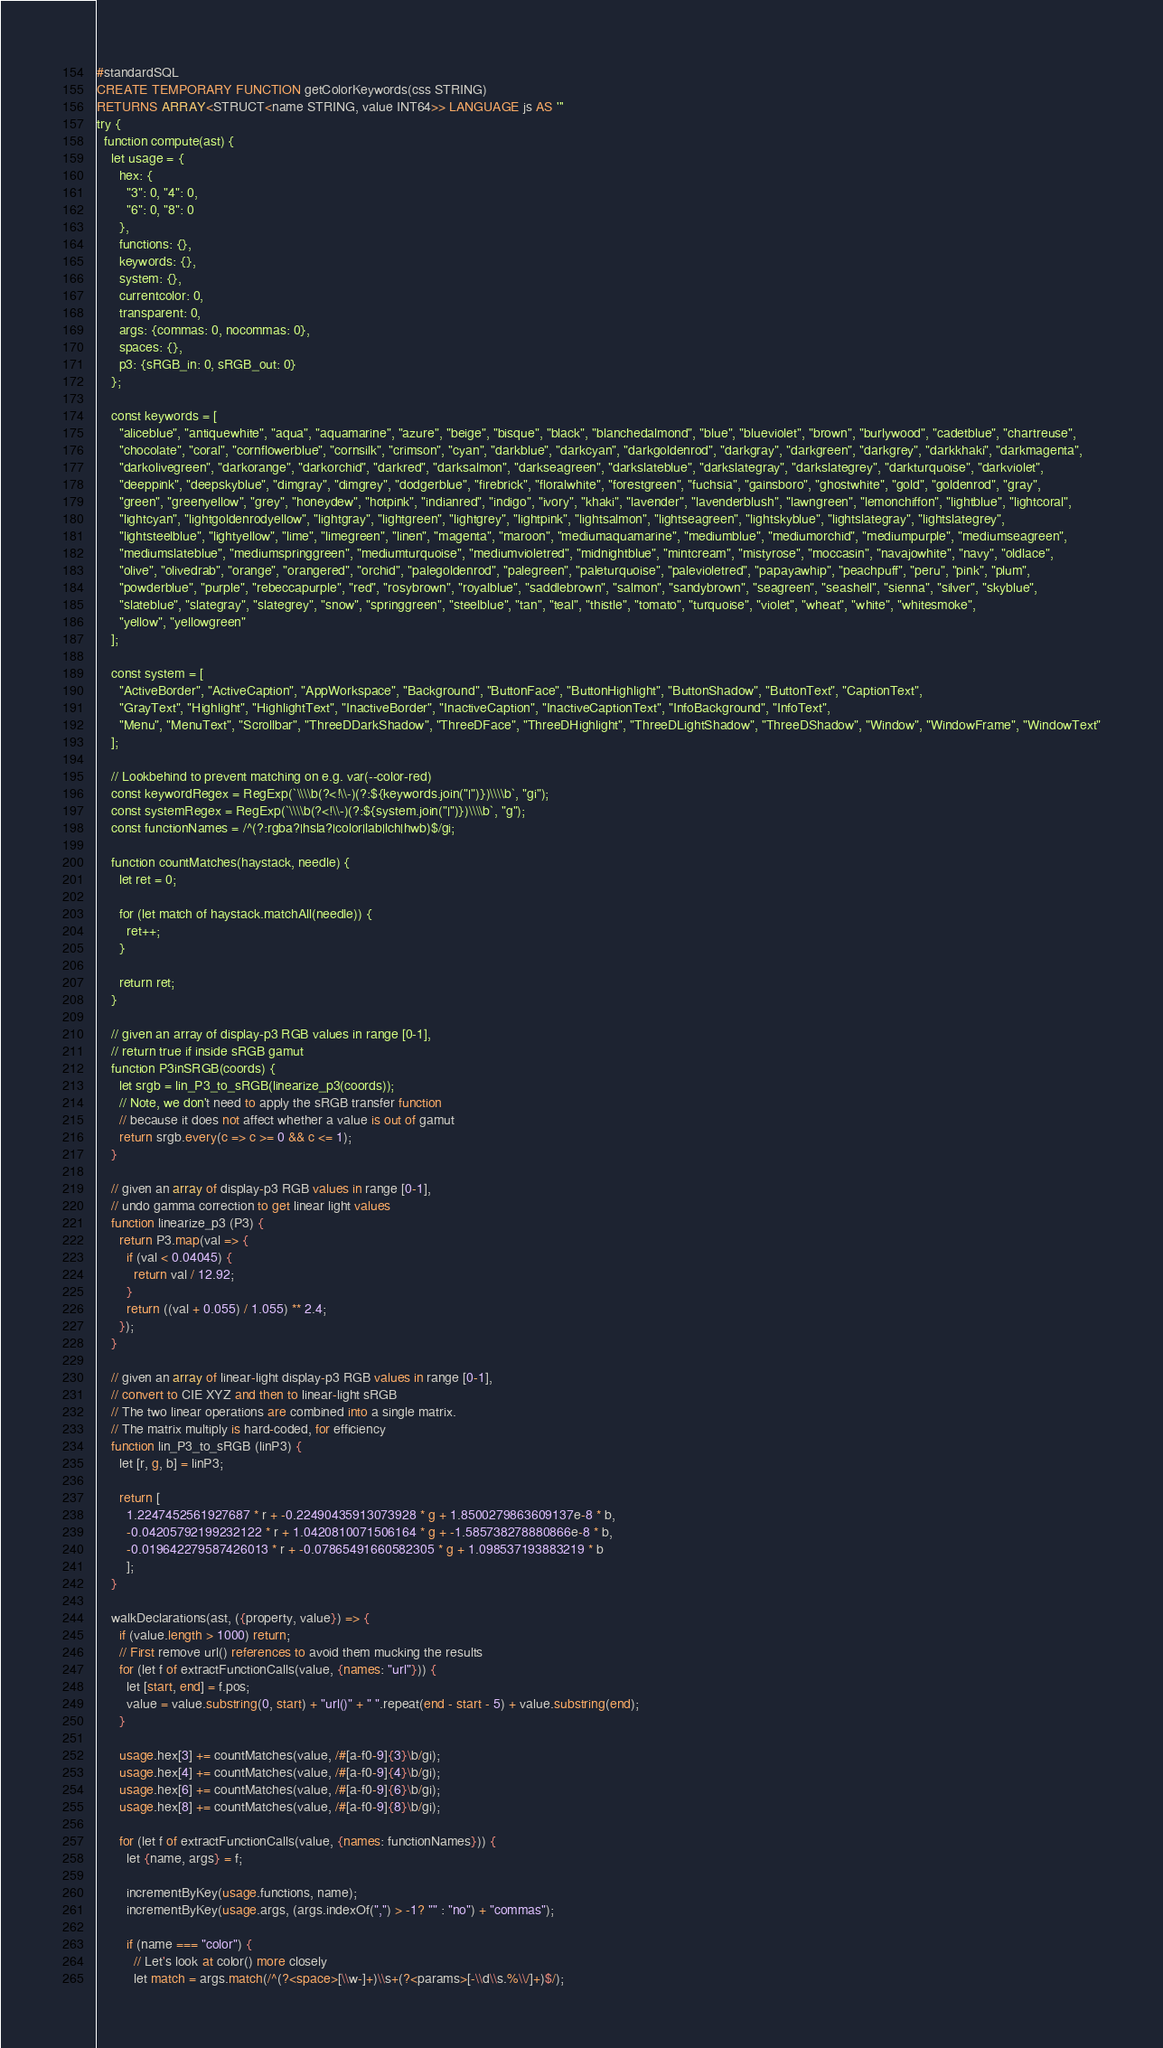<code> <loc_0><loc_0><loc_500><loc_500><_SQL_>#standardSQL
CREATE TEMPORARY FUNCTION getColorKeywords(css STRING)
RETURNS ARRAY<STRUCT<name STRING, value INT64>> LANGUAGE js AS '''
try {
  function compute(ast) {
    let usage = {
      hex: {
        "3": 0, "4": 0,
        "6": 0, "8": 0
      },
      functions: {},
      keywords: {},
      system: {},
      currentcolor: 0,
      transparent: 0,
      args: {commas: 0, nocommas: 0},
      spaces: {},
      p3: {sRGB_in: 0, sRGB_out: 0}
    };

    const keywords = [
      "aliceblue", "antiquewhite", "aqua", "aquamarine", "azure", "beige", "bisque", "black", "blanchedalmond", "blue", "blueviolet", "brown", "burlywood", "cadetblue", "chartreuse",
      "chocolate", "coral", "cornflowerblue", "cornsilk", "crimson", "cyan", "darkblue", "darkcyan", "darkgoldenrod", "darkgray", "darkgreen", "darkgrey", "darkkhaki", "darkmagenta",
      "darkolivegreen", "darkorange", "darkorchid", "darkred", "darksalmon", "darkseagreen", "darkslateblue", "darkslategray", "darkslategrey", "darkturquoise", "darkviolet",
      "deeppink", "deepskyblue", "dimgray", "dimgrey", "dodgerblue", "firebrick", "floralwhite", "forestgreen", "fuchsia", "gainsboro", "ghostwhite", "gold", "goldenrod", "gray",
      "green", "greenyellow", "grey", "honeydew", "hotpink", "indianred", "indigo", "ivory", "khaki", "lavender", "lavenderblush", "lawngreen", "lemonchiffon", "lightblue", "lightcoral",
      "lightcyan", "lightgoldenrodyellow", "lightgray", "lightgreen", "lightgrey", "lightpink", "lightsalmon", "lightseagreen", "lightskyblue", "lightslategray", "lightslategrey",
      "lightsteelblue", "lightyellow", "lime", "limegreen", "linen", "magenta", "maroon", "mediumaquamarine", "mediumblue", "mediumorchid", "mediumpurple", "mediumseagreen",
      "mediumslateblue", "mediumspringgreen", "mediumturquoise", "mediumvioletred", "midnightblue", "mintcream", "mistyrose", "moccasin", "navajowhite", "navy", "oldlace",
      "olive", "olivedrab", "orange", "orangered", "orchid", "palegoldenrod", "palegreen", "paleturquoise", "palevioletred", "papayawhip", "peachpuff", "peru", "pink", "plum",
      "powderblue", "purple", "rebeccapurple", "red", "rosybrown", "royalblue", "saddlebrown", "salmon", "sandybrown", "seagreen", "seashell", "sienna", "silver", "skyblue",
      "slateblue", "slategray", "slategrey", "snow", "springgreen", "steelblue", "tan", "teal", "thistle", "tomato", "turquoise", "violet", "wheat", "white", "whitesmoke",
      "yellow", "yellowgreen"
    ];

    const system = [
      "ActiveBorder", "ActiveCaption", "AppWorkspace", "Background", "ButtonFace", "ButtonHighlight", "ButtonShadow", "ButtonText", "CaptionText",
      "GrayText", "Highlight", "HighlightText", "InactiveBorder", "InactiveCaption", "InactiveCaptionText", "InfoBackground", "InfoText",
      "Menu", "MenuText", "Scrollbar", "ThreeDDarkShadow", "ThreeDFace", "ThreeDHighlight", "ThreeDLightShadow", "ThreeDShadow", "Window", "WindowFrame", "WindowText"
    ];

    // Lookbehind to prevent matching on e.g. var(--color-red)
    const keywordRegex = RegExp(`\\\\b(?<!\\-)(?:${keywords.join("|")})\\\\b`, "gi");
    const systemRegex = RegExp(`\\\\b(?<!\\-)(?:${system.join("|")})\\\\b`, "g");
    const functionNames = /^(?:rgba?|hsla?|color|lab|lch|hwb)$/gi;

    function countMatches(haystack, needle) {
      let ret = 0;

      for (let match of haystack.matchAll(needle)) {
        ret++;
      }

      return ret;
    }

    // given an array of display-p3 RGB values in range [0-1],
    // return true if inside sRGB gamut
    function P3inSRGB(coords) {
      let srgb = lin_P3_to_sRGB(linearize_p3(coords));
      // Note, we don't need to apply the sRGB transfer function
      // because it does not affect whether a value is out of gamut
      return srgb.every(c => c >= 0 && c <= 1);
    }

    // given an array of display-p3 RGB values in range [0-1],
    // undo gamma correction to get linear light values
    function linearize_p3 (P3) {
      return P3.map(val => {
        if (val < 0.04045) {
          return val / 12.92;
        }
        return ((val + 0.055) / 1.055) ** 2.4;
      });
    }

    // given an array of linear-light display-p3 RGB values in range [0-1],
    // convert to CIE XYZ and then to linear-light sRGB
    // The two linear operations are combined into a single matrix.
    // The matrix multiply is hard-coded, for efficiency
    function lin_P3_to_sRGB (linP3) {
      let [r, g, b] = linP3;

      return [
        1.2247452561927687 * r + -0.22490435913073928 * g + 1.8500279863609137e-8 * b,
        -0.04205792199232122 * r + 1.0420810071506164 * g + -1.585738278880866e-8 * b,
        -0.019642279587426013 * r + -0.07865491660582305 * g + 1.098537193883219 * b
        ];
    }

    walkDeclarations(ast, ({property, value}) => {
      if (value.length > 1000) return;
      // First remove url() references to avoid them mucking the results
      for (let f of extractFunctionCalls(value, {names: "url"})) {
        let [start, end] = f.pos;
        value = value.substring(0, start) + "url()" + " ".repeat(end - start - 5) + value.substring(end);
      }

      usage.hex[3] += countMatches(value, /#[a-f0-9]{3}\b/gi);
      usage.hex[4] += countMatches(value, /#[a-f0-9]{4}\b/gi);
      usage.hex[6] += countMatches(value, /#[a-f0-9]{6}\b/gi);
      usage.hex[8] += countMatches(value, /#[a-f0-9]{8}\b/gi);

      for (let f of extractFunctionCalls(value, {names: functionNames})) {
        let {name, args} = f;

        incrementByKey(usage.functions, name);
        incrementByKey(usage.args, (args.indexOf(",") > -1? "" : "no") + "commas");

        if (name === "color") {
          // Let's look at color() more closely
          let match = args.match(/^(?<space>[\\w-]+)\\s+(?<params>[-\\d\\s.%\\/]+)$/);
</code> 